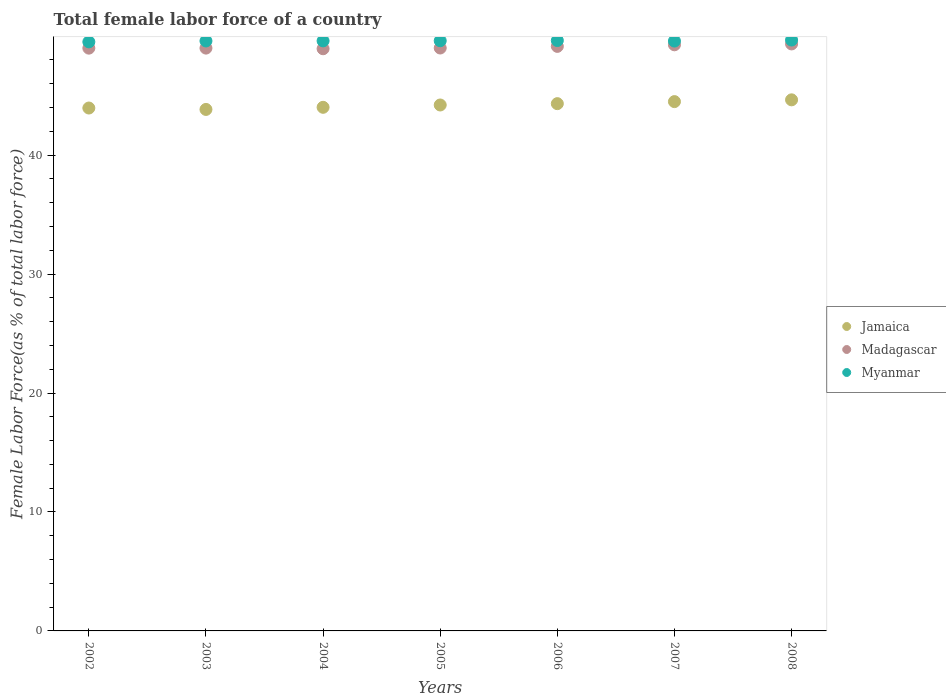How many different coloured dotlines are there?
Provide a succinct answer. 3. What is the percentage of female labor force in Jamaica in 2008?
Provide a short and direct response. 44.65. Across all years, what is the maximum percentage of female labor force in Madagascar?
Make the answer very short. 49.35. Across all years, what is the minimum percentage of female labor force in Jamaica?
Give a very brief answer. 43.84. What is the total percentage of female labor force in Myanmar in the graph?
Ensure brevity in your answer.  347.24. What is the difference between the percentage of female labor force in Jamaica in 2003 and that in 2007?
Ensure brevity in your answer.  -0.66. What is the difference between the percentage of female labor force in Myanmar in 2006 and the percentage of female labor force in Jamaica in 2007?
Provide a succinct answer. 5.13. What is the average percentage of female labor force in Jamaica per year?
Make the answer very short. 44.22. In the year 2002, what is the difference between the percentage of female labor force in Jamaica and percentage of female labor force in Myanmar?
Keep it short and to the point. -5.56. In how many years, is the percentage of female labor force in Madagascar greater than 36 %?
Offer a terse response. 7. What is the ratio of the percentage of female labor force in Myanmar in 2002 to that in 2006?
Ensure brevity in your answer.  1. Is the difference between the percentage of female labor force in Jamaica in 2003 and 2008 greater than the difference between the percentage of female labor force in Myanmar in 2003 and 2008?
Ensure brevity in your answer.  No. What is the difference between the highest and the second highest percentage of female labor force in Jamaica?
Provide a short and direct response. 0.15. What is the difference between the highest and the lowest percentage of female labor force in Myanmar?
Your answer should be very brief. 0.15. Is the sum of the percentage of female labor force in Jamaica in 2004 and 2005 greater than the maximum percentage of female labor force in Madagascar across all years?
Your answer should be very brief. Yes. Does the percentage of female labor force in Madagascar monotonically increase over the years?
Give a very brief answer. No. Is the percentage of female labor force in Jamaica strictly less than the percentage of female labor force in Madagascar over the years?
Your answer should be compact. Yes. How many dotlines are there?
Give a very brief answer. 3. How many years are there in the graph?
Ensure brevity in your answer.  7. Does the graph contain grids?
Your response must be concise. No. Where does the legend appear in the graph?
Your answer should be very brief. Center right. How many legend labels are there?
Your answer should be very brief. 3. How are the legend labels stacked?
Offer a very short reply. Vertical. What is the title of the graph?
Offer a very short reply. Total female labor force of a country. Does "Azerbaijan" appear as one of the legend labels in the graph?
Offer a terse response. No. What is the label or title of the X-axis?
Offer a terse response. Years. What is the label or title of the Y-axis?
Your response must be concise. Female Labor Force(as % of total labor force). What is the Female Labor Force(as % of total labor force) of Jamaica in 2002?
Offer a terse response. 43.96. What is the Female Labor Force(as % of total labor force) in Madagascar in 2002?
Your answer should be compact. 48.99. What is the Female Labor Force(as % of total labor force) of Myanmar in 2002?
Provide a short and direct response. 49.52. What is the Female Labor Force(as % of total labor force) of Jamaica in 2003?
Provide a short and direct response. 43.84. What is the Female Labor Force(as % of total labor force) of Madagascar in 2003?
Give a very brief answer. 49. What is the Female Labor Force(as % of total labor force) of Myanmar in 2003?
Provide a succinct answer. 49.6. What is the Female Labor Force(as % of total labor force) of Jamaica in 2004?
Provide a succinct answer. 44.02. What is the Female Labor Force(as % of total labor force) of Madagascar in 2004?
Make the answer very short. 48.94. What is the Female Labor Force(as % of total labor force) of Myanmar in 2004?
Give a very brief answer. 49.6. What is the Female Labor Force(as % of total labor force) in Jamaica in 2005?
Provide a succinct answer. 44.22. What is the Female Labor Force(as % of total labor force) in Madagascar in 2005?
Provide a succinct answer. 49.01. What is the Female Labor Force(as % of total labor force) of Myanmar in 2005?
Keep it short and to the point. 49.62. What is the Female Labor Force(as % of total labor force) in Jamaica in 2006?
Provide a short and direct response. 44.33. What is the Female Labor Force(as % of total labor force) of Madagascar in 2006?
Keep it short and to the point. 49.14. What is the Female Labor Force(as % of total labor force) in Myanmar in 2006?
Offer a very short reply. 49.63. What is the Female Labor Force(as % of total labor force) of Jamaica in 2007?
Your response must be concise. 44.5. What is the Female Labor Force(as % of total labor force) in Madagascar in 2007?
Keep it short and to the point. 49.28. What is the Female Labor Force(as % of total labor force) in Myanmar in 2007?
Provide a succinct answer. 49.59. What is the Female Labor Force(as % of total labor force) of Jamaica in 2008?
Offer a very short reply. 44.65. What is the Female Labor Force(as % of total labor force) in Madagascar in 2008?
Keep it short and to the point. 49.35. What is the Female Labor Force(as % of total labor force) of Myanmar in 2008?
Keep it short and to the point. 49.68. Across all years, what is the maximum Female Labor Force(as % of total labor force) of Jamaica?
Ensure brevity in your answer.  44.65. Across all years, what is the maximum Female Labor Force(as % of total labor force) in Madagascar?
Provide a succinct answer. 49.35. Across all years, what is the maximum Female Labor Force(as % of total labor force) of Myanmar?
Your answer should be very brief. 49.68. Across all years, what is the minimum Female Labor Force(as % of total labor force) in Jamaica?
Make the answer very short. 43.84. Across all years, what is the minimum Female Labor Force(as % of total labor force) in Madagascar?
Give a very brief answer. 48.94. Across all years, what is the minimum Female Labor Force(as % of total labor force) in Myanmar?
Your answer should be very brief. 49.52. What is the total Female Labor Force(as % of total labor force) of Jamaica in the graph?
Your answer should be very brief. 309.51. What is the total Female Labor Force(as % of total labor force) of Madagascar in the graph?
Ensure brevity in your answer.  343.71. What is the total Female Labor Force(as % of total labor force) in Myanmar in the graph?
Your answer should be compact. 347.24. What is the difference between the Female Labor Force(as % of total labor force) of Jamaica in 2002 and that in 2003?
Your response must be concise. 0.12. What is the difference between the Female Labor Force(as % of total labor force) in Madagascar in 2002 and that in 2003?
Offer a terse response. -0. What is the difference between the Female Labor Force(as % of total labor force) of Myanmar in 2002 and that in 2003?
Keep it short and to the point. -0.08. What is the difference between the Female Labor Force(as % of total labor force) in Jamaica in 2002 and that in 2004?
Make the answer very short. -0.06. What is the difference between the Female Labor Force(as % of total labor force) of Myanmar in 2002 and that in 2004?
Provide a succinct answer. -0.08. What is the difference between the Female Labor Force(as % of total labor force) of Jamaica in 2002 and that in 2005?
Provide a short and direct response. -0.26. What is the difference between the Female Labor Force(as % of total labor force) in Madagascar in 2002 and that in 2005?
Your response must be concise. -0.01. What is the difference between the Female Labor Force(as % of total labor force) of Myanmar in 2002 and that in 2005?
Provide a succinct answer. -0.09. What is the difference between the Female Labor Force(as % of total labor force) in Jamaica in 2002 and that in 2006?
Provide a succinct answer. -0.37. What is the difference between the Female Labor Force(as % of total labor force) of Madagascar in 2002 and that in 2006?
Offer a very short reply. -0.15. What is the difference between the Female Labor Force(as % of total labor force) in Myanmar in 2002 and that in 2006?
Offer a very short reply. -0.11. What is the difference between the Female Labor Force(as % of total labor force) in Jamaica in 2002 and that in 2007?
Your answer should be compact. -0.54. What is the difference between the Female Labor Force(as % of total labor force) in Madagascar in 2002 and that in 2007?
Offer a very short reply. -0.28. What is the difference between the Female Labor Force(as % of total labor force) in Myanmar in 2002 and that in 2007?
Ensure brevity in your answer.  -0.07. What is the difference between the Female Labor Force(as % of total labor force) in Jamaica in 2002 and that in 2008?
Ensure brevity in your answer.  -0.69. What is the difference between the Female Labor Force(as % of total labor force) in Madagascar in 2002 and that in 2008?
Keep it short and to the point. -0.35. What is the difference between the Female Labor Force(as % of total labor force) in Myanmar in 2002 and that in 2008?
Make the answer very short. -0.15. What is the difference between the Female Labor Force(as % of total labor force) of Jamaica in 2003 and that in 2004?
Provide a succinct answer. -0.18. What is the difference between the Female Labor Force(as % of total labor force) of Madagascar in 2003 and that in 2004?
Provide a short and direct response. 0.05. What is the difference between the Female Labor Force(as % of total labor force) in Myanmar in 2003 and that in 2004?
Offer a very short reply. -0.01. What is the difference between the Female Labor Force(as % of total labor force) in Jamaica in 2003 and that in 2005?
Offer a very short reply. -0.37. What is the difference between the Female Labor Force(as % of total labor force) of Madagascar in 2003 and that in 2005?
Give a very brief answer. -0.01. What is the difference between the Female Labor Force(as % of total labor force) of Myanmar in 2003 and that in 2005?
Offer a very short reply. -0.02. What is the difference between the Female Labor Force(as % of total labor force) in Jamaica in 2003 and that in 2006?
Offer a terse response. -0.49. What is the difference between the Female Labor Force(as % of total labor force) in Madagascar in 2003 and that in 2006?
Your answer should be very brief. -0.15. What is the difference between the Female Labor Force(as % of total labor force) of Myanmar in 2003 and that in 2006?
Offer a very short reply. -0.04. What is the difference between the Female Labor Force(as % of total labor force) in Jamaica in 2003 and that in 2007?
Your response must be concise. -0.66. What is the difference between the Female Labor Force(as % of total labor force) in Madagascar in 2003 and that in 2007?
Your response must be concise. -0.28. What is the difference between the Female Labor Force(as % of total labor force) in Myanmar in 2003 and that in 2007?
Make the answer very short. 0.01. What is the difference between the Female Labor Force(as % of total labor force) of Jamaica in 2003 and that in 2008?
Offer a terse response. -0.81. What is the difference between the Female Labor Force(as % of total labor force) in Madagascar in 2003 and that in 2008?
Make the answer very short. -0.35. What is the difference between the Female Labor Force(as % of total labor force) in Myanmar in 2003 and that in 2008?
Ensure brevity in your answer.  -0.08. What is the difference between the Female Labor Force(as % of total labor force) in Jamaica in 2004 and that in 2005?
Your answer should be very brief. -0.2. What is the difference between the Female Labor Force(as % of total labor force) of Madagascar in 2004 and that in 2005?
Offer a terse response. -0.06. What is the difference between the Female Labor Force(as % of total labor force) in Myanmar in 2004 and that in 2005?
Provide a short and direct response. -0.01. What is the difference between the Female Labor Force(as % of total labor force) of Jamaica in 2004 and that in 2006?
Make the answer very short. -0.31. What is the difference between the Female Labor Force(as % of total labor force) of Madagascar in 2004 and that in 2006?
Your answer should be compact. -0.2. What is the difference between the Female Labor Force(as % of total labor force) in Myanmar in 2004 and that in 2006?
Keep it short and to the point. -0.03. What is the difference between the Female Labor Force(as % of total labor force) in Jamaica in 2004 and that in 2007?
Keep it short and to the point. -0.48. What is the difference between the Female Labor Force(as % of total labor force) in Madagascar in 2004 and that in 2007?
Provide a short and direct response. -0.33. What is the difference between the Female Labor Force(as % of total labor force) in Myanmar in 2004 and that in 2007?
Offer a very short reply. 0.02. What is the difference between the Female Labor Force(as % of total labor force) in Jamaica in 2004 and that in 2008?
Ensure brevity in your answer.  -0.63. What is the difference between the Female Labor Force(as % of total labor force) of Madagascar in 2004 and that in 2008?
Your answer should be compact. -0.41. What is the difference between the Female Labor Force(as % of total labor force) in Myanmar in 2004 and that in 2008?
Your answer should be compact. -0.07. What is the difference between the Female Labor Force(as % of total labor force) in Jamaica in 2005 and that in 2006?
Ensure brevity in your answer.  -0.11. What is the difference between the Female Labor Force(as % of total labor force) in Madagascar in 2005 and that in 2006?
Keep it short and to the point. -0.14. What is the difference between the Female Labor Force(as % of total labor force) in Myanmar in 2005 and that in 2006?
Make the answer very short. -0.02. What is the difference between the Female Labor Force(as % of total labor force) in Jamaica in 2005 and that in 2007?
Your answer should be very brief. -0.28. What is the difference between the Female Labor Force(as % of total labor force) of Madagascar in 2005 and that in 2007?
Keep it short and to the point. -0.27. What is the difference between the Female Labor Force(as % of total labor force) in Myanmar in 2005 and that in 2007?
Keep it short and to the point. 0.03. What is the difference between the Female Labor Force(as % of total labor force) in Jamaica in 2005 and that in 2008?
Provide a short and direct response. -0.43. What is the difference between the Female Labor Force(as % of total labor force) in Madagascar in 2005 and that in 2008?
Give a very brief answer. -0.34. What is the difference between the Female Labor Force(as % of total labor force) of Myanmar in 2005 and that in 2008?
Your answer should be compact. -0.06. What is the difference between the Female Labor Force(as % of total labor force) in Jamaica in 2006 and that in 2007?
Provide a short and direct response. -0.17. What is the difference between the Female Labor Force(as % of total labor force) of Madagascar in 2006 and that in 2007?
Give a very brief answer. -0.13. What is the difference between the Female Labor Force(as % of total labor force) in Myanmar in 2006 and that in 2007?
Your answer should be compact. 0.04. What is the difference between the Female Labor Force(as % of total labor force) in Jamaica in 2006 and that in 2008?
Offer a terse response. -0.32. What is the difference between the Female Labor Force(as % of total labor force) of Madagascar in 2006 and that in 2008?
Your answer should be very brief. -0.21. What is the difference between the Female Labor Force(as % of total labor force) of Myanmar in 2006 and that in 2008?
Provide a short and direct response. -0.04. What is the difference between the Female Labor Force(as % of total labor force) of Jamaica in 2007 and that in 2008?
Give a very brief answer. -0.15. What is the difference between the Female Labor Force(as % of total labor force) of Madagascar in 2007 and that in 2008?
Provide a short and direct response. -0.07. What is the difference between the Female Labor Force(as % of total labor force) in Myanmar in 2007 and that in 2008?
Give a very brief answer. -0.09. What is the difference between the Female Labor Force(as % of total labor force) of Jamaica in 2002 and the Female Labor Force(as % of total labor force) of Madagascar in 2003?
Ensure brevity in your answer.  -5.04. What is the difference between the Female Labor Force(as % of total labor force) in Jamaica in 2002 and the Female Labor Force(as % of total labor force) in Myanmar in 2003?
Make the answer very short. -5.64. What is the difference between the Female Labor Force(as % of total labor force) in Madagascar in 2002 and the Female Labor Force(as % of total labor force) in Myanmar in 2003?
Keep it short and to the point. -0.6. What is the difference between the Female Labor Force(as % of total labor force) in Jamaica in 2002 and the Female Labor Force(as % of total labor force) in Madagascar in 2004?
Keep it short and to the point. -4.98. What is the difference between the Female Labor Force(as % of total labor force) in Jamaica in 2002 and the Female Labor Force(as % of total labor force) in Myanmar in 2004?
Keep it short and to the point. -5.65. What is the difference between the Female Labor Force(as % of total labor force) in Madagascar in 2002 and the Female Labor Force(as % of total labor force) in Myanmar in 2004?
Ensure brevity in your answer.  -0.61. What is the difference between the Female Labor Force(as % of total labor force) of Jamaica in 2002 and the Female Labor Force(as % of total labor force) of Madagascar in 2005?
Offer a very short reply. -5.05. What is the difference between the Female Labor Force(as % of total labor force) of Jamaica in 2002 and the Female Labor Force(as % of total labor force) of Myanmar in 2005?
Provide a short and direct response. -5.66. What is the difference between the Female Labor Force(as % of total labor force) in Madagascar in 2002 and the Female Labor Force(as % of total labor force) in Myanmar in 2005?
Offer a very short reply. -0.62. What is the difference between the Female Labor Force(as % of total labor force) in Jamaica in 2002 and the Female Labor Force(as % of total labor force) in Madagascar in 2006?
Provide a short and direct response. -5.18. What is the difference between the Female Labor Force(as % of total labor force) of Jamaica in 2002 and the Female Labor Force(as % of total labor force) of Myanmar in 2006?
Provide a succinct answer. -5.67. What is the difference between the Female Labor Force(as % of total labor force) of Madagascar in 2002 and the Female Labor Force(as % of total labor force) of Myanmar in 2006?
Offer a very short reply. -0.64. What is the difference between the Female Labor Force(as % of total labor force) of Jamaica in 2002 and the Female Labor Force(as % of total labor force) of Madagascar in 2007?
Make the answer very short. -5.32. What is the difference between the Female Labor Force(as % of total labor force) in Jamaica in 2002 and the Female Labor Force(as % of total labor force) in Myanmar in 2007?
Your answer should be very brief. -5.63. What is the difference between the Female Labor Force(as % of total labor force) of Madagascar in 2002 and the Female Labor Force(as % of total labor force) of Myanmar in 2007?
Ensure brevity in your answer.  -0.6. What is the difference between the Female Labor Force(as % of total labor force) of Jamaica in 2002 and the Female Labor Force(as % of total labor force) of Madagascar in 2008?
Give a very brief answer. -5.39. What is the difference between the Female Labor Force(as % of total labor force) of Jamaica in 2002 and the Female Labor Force(as % of total labor force) of Myanmar in 2008?
Offer a terse response. -5.72. What is the difference between the Female Labor Force(as % of total labor force) of Madagascar in 2002 and the Female Labor Force(as % of total labor force) of Myanmar in 2008?
Your answer should be compact. -0.68. What is the difference between the Female Labor Force(as % of total labor force) in Jamaica in 2003 and the Female Labor Force(as % of total labor force) in Madagascar in 2004?
Your answer should be compact. -5.1. What is the difference between the Female Labor Force(as % of total labor force) of Jamaica in 2003 and the Female Labor Force(as % of total labor force) of Myanmar in 2004?
Make the answer very short. -5.76. What is the difference between the Female Labor Force(as % of total labor force) in Madagascar in 2003 and the Female Labor Force(as % of total labor force) in Myanmar in 2004?
Ensure brevity in your answer.  -0.61. What is the difference between the Female Labor Force(as % of total labor force) in Jamaica in 2003 and the Female Labor Force(as % of total labor force) in Madagascar in 2005?
Keep it short and to the point. -5.16. What is the difference between the Female Labor Force(as % of total labor force) of Jamaica in 2003 and the Female Labor Force(as % of total labor force) of Myanmar in 2005?
Your answer should be compact. -5.77. What is the difference between the Female Labor Force(as % of total labor force) in Madagascar in 2003 and the Female Labor Force(as % of total labor force) in Myanmar in 2005?
Give a very brief answer. -0.62. What is the difference between the Female Labor Force(as % of total labor force) in Jamaica in 2003 and the Female Labor Force(as % of total labor force) in Madagascar in 2006?
Make the answer very short. -5.3. What is the difference between the Female Labor Force(as % of total labor force) of Jamaica in 2003 and the Female Labor Force(as % of total labor force) of Myanmar in 2006?
Make the answer very short. -5.79. What is the difference between the Female Labor Force(as % of total labor force) in Madagascar in 2003 and the Female Labor Force(as % of total labor force) in Myanmar in 2006?
Keep it short and to the point. -0.64. What is the difference between the Female Labor Force(as % of total labor force) of Jamaica in 2003 and the Female Labor Force(as % of total labor force) of Madagascar in 2007?
Provide a succinct answer. -5.43. What is the difference between the Female Labor Force(as % of total labor force) of Jamaica in 2003 and the Female Labor Force(as % of total labor force) of Myanmar in 2007?
Your response must be concise. -5.75. What is the difference between the Female Labor Force(as % of total labor force) in Madagascar in 2003 and the Female Labor Force(as % of total labor force) in Myanmar in 2007?
Ensure brevity in your answer.  -0.59. What is the difference between the Female Labor Force(as % of total labor force) of Jamaica in 2003 and the Female Labor Force(as % of total labor force) of Madagascar in 2008?
Your answer should be very brief. -5.51. What is the difference between the Female Labor Force(as % of total labor force) in Jamaica in 2003 and the Female Labor Force(as % of total labor force) in Myanmar in 2008?
Provide a succinct answer. -5.83. What is the difference between the Female Labor Force(as % of total labor force) of Madagascar in 2003 and the Female Labor Force(as % of total labor force) of Myanmar in 2008?
Make the answer very short. -0.68. What is the difference between the Female Labor Force(as % of total labor force) of Jamaica in 2004 and the Female Labor Force(as % of total labor force) of Madagascar in 2005?
Offer a very short reply. -4.99. What is the difference between the Female Labor Force(as % of total labor force) of Jamaica in 2004 and the Female Labor Force(as % of total labor force) of Myanmar in 2005?
Ensure brevity in your answer.  -5.6. What is the difference between the Female Labor Force(as % of total labor force) of Madagascar in 2004 and the Female Labor Force(as % of total labor force) of Myanmar in 2005?
Provide a succinct answer. -0.67. What is the difference between the Female Labor Force(as % of total labor force) in Jamaica in 2004 and the Female Labor Force(as % of total labor force) in Madagascar in 2006?
Your response must be concise. -5.12. What is the difference between the Female Labor Force(as % of total labor force) in Jamaica in 2004 and the Female Labor Force(as % of total labor force) in Myanmar in 2006?
Keep it short and to the point. -5.61. What is the difference between the Female Labor Force(as % of total labor force) of Madagascar in 2004 and the Female Labor Force(as % of total labor force) of Myanmar in 2006?
Provide a succinct answer. -0.69. What is the difference between the Female Labor Force(as % of total labor force) of Jamaica in 2004 and the Female Labor Force(as % of total labor force) of Madagascar in 2007?
Offer a very short reply. -5.26. What is the difference between the Female Labor Force(as % of total labor force) in Jamaica in 2004 and the Female Labor Force(as % of total labor force) in Myanmar in 2007?
Your answer should be very brief. -5.57. What is the difference between the Female Labor Force(as % of total labor force) in Madagascar in 2004 and the Female Labor Force(as % of total labor force) in Myanmar in 2007?
Provide a short and direct response. -0.65. What is the difference between the Female Labor Force(as % of total labor force) of Jamaica in 2004 and the Female Labor Force(as % of total labor force) of Madagascar in 2008?
Give a very brief answer. -5.33. What is the difference between the Female Labor Force(as % of total labor force) in Jamaica in 2004 and the Female Labor Force(as % of total labor force) in Myanmar in 2008?
Give a very brief answer. -5.66. What is the difference between the Female Labor Force(as % of total labor force) of Madagascar in 2004 and the Female Labor Force(as % of total labor force) of Myanmar in 2008?
Keep it short and to the point. -0.73. What is the difference between the Female Labor Force(as % of total labor force) of Jamaica in 2005 and the Female Labor Force(as % of total labor force) of Madagascar in 2006?
Provide a succinct answer. -4.93. What is the difference between the Female Labor Force(as % of total labor force) in Jamaica in 2005 and the Female Labor Force(as % of total labor force) in Myanmar in 2006?
Your answer should be compact. -5.42. What is the difference between the Female Labor Force(as % of total labor force) of Madagascar in 2005 and the Female Labor Force(as % of total labor force) of Myanmar in 2006?
Offer a very short reply. -0.63. What is the difference between the Female Labor Force(as % of total labor force) in Jamaica in 2005 and the Female Labor Force(as % of total labor force) in Madagascar in 2007?
Your response must be concise. -5.06. What is the difference between the Female Labor Force(as % of total labor force) in Jamaica in 2005 and the Female Labor Force(as % of total labor force) in Myanmar in 2007?
Give a very brief answer. -5.37. What is the difference between the Female Labor Force(as % of total labor force) in Madagascar in 2005 and the Female Labor Force(as % of total labor force) in Myanmar in 2007?
Provide a succinct answer. -0.58. What is the difference between the Female Labor Force(as % of total labor force) of Jamaica in 2005 and the Female Labor Force(as % of total labor force) of Madagascar in 2008?
Offer a terse response. -5.13. What is the difference between the Female Labor Force(as % of total labor force) of Jamaica in 2005 and the Female Labor Force(as % of total labor force) of Myanmar in 2008?
Provide a succinct answer. -5.46. What is the difference between the Female Labor Force(as % of total labor force) in Madagascar in 2005 and the Female Labor Force(as % of total labor force) in Myanmar in 2008?
Ensure brevity in your answer.  -0.67. What is the difference between the Female Labor Force(as % of total labor force) in Jamaica in 2006 and the Female Labor Force(as % of total labor force) in Madagascar in 2007?
Make the answer very short. -4.95. What is the difference between the Female Labor Force(as % of total labor force) of Jamaica in 2006 and the Female Labor Force(as % of total labor force) of Myanmar in 2007?
Ensure brevity in your answer.  -5.26. What is the difference between the Female Labor Force(as % of total labor force) in Madagascar in 2006 and the Female Labor Force(as % of total labor force) in Myanmar in 2007?
Your response must be concise. -0.45. What is the difference between the Female Labor Force(as % of total labor force) of Jamaica in 2006 and the Female Labor Force(as % of total labor force) of Madagascar in 2008?
Your answer should be compact. -5.02. What is the difference between the Female Labor Force(as % of total labor force) of Jamaica in 2006 and the Female Labor Force(as % of total labor force) of Myanmar in 2008?
Ensure brevity in your answer.  -5.35. What is the difference between the Female Labor Force(as % of total labor force) of Madagascar in 2006 and the Female Labor Force(as % of total labor force) of Myanmar in 2008?
Ensure brevity in your answer.  -0.53. What is the difference between the Female Labor Force(as % of total labor force) of Jamaica in 2007 and the Female Labor Force(as % of total labor force) of Madagascar in 2008?
Your answer should be very brief. -4.85. What is the difference between the Female Labor Force(as % of total labor force) in Jamaica in 2007 and the Female Labor Force(as % of total labor force) in Myanmar in 2008?
Your answer should be very brief. -5.18. What is the difference between the Female Labor Force(as % of total labor force) in Madagascar in 2007 and the Female Labor Force(as % of total labor force) in Myanmar in 2008?
Offer a very short reply. -0.4. What is the average Female Labor Force(as % of total labor force) of Jamaica per year?
Provide a short and direct response. 44.22. What is the average Female Labor Force(as % of total labor force) in Madagascar per year?
Your response must be concise. 49.1. What is the average Female Labor Force(as % of total labor force) in Myanmar per year?
Give a very brief answer. 49.61. In the year 2002, what is the difference between the Female Labor Force(as % of total labor force) in Jamaica and Female Labor Force(as % of total labor force) in Madagascar?
Make the answer very short. -5.03. In the year 2002, what is the difference between the Female Labor Force(as % of total labor force) of Jamaica and Female Labor Force(as % of total labor force) of Myanmar?
Offer a terse response. -5.56. In the year 2002, what is the difference between the Female Labor Force(as % of total labor force) of Madagascar and Female Labor Force(as % of total labor force) of Myanmar?
Provide a short and direct response. -0.53. In the year 2003, what is the difference between the Female Labor Force(as % of total labor force) in Jamaica and Female Labor Force(as % of total labor force) in Madagascar?
Your response must be concise. -5.16. In the year 2003, what is the difference between the Female Labor Force(as % of total labor force) in Jamaica and Female Labor Force(as % of total labor force) in Myanmar?
Your answer should be compact. -5.76. In the year 2003, what is the difference between the Female Labor Force(as % of total labor force) of Madagascar and Female Labor Force(as % of total labor force) of Myanmar?
Give a very brief answer. -0.6. In the year 2004, what is the difference between the Female Labor Force(as % of total labor force) of Jamaica and Female Labor Force(as % of total labor force) of Madagascar?
Keep it short and to the point. -4.92. In the year 2004, what is the difference between the Female Labor Force(as % of total labor force) of Jamaica and Female Labor Force(as % of total labor force) of Myanmar?
Give a very brief answer. -5.58. In the year 2004, what is the difference between the Female Labor Force(as % of total labor force) of Madagascar and Female Labor Force(as % of total labor force) of Myanmar?
Provide a short and direct response. -0.66. In the year 2005, what is the difference between the Female Labor Force(as % of total labor force) of Jamaica and Female Labor Force(as % of total labor force) of Madagascar?
Your answer should be compact. -4.79. In the year 2005, what is the difference between the Female Labor Force(as % of total labor force) of Jamaica and Female Labor Force(as % of total labor force) of Myanmar?
Your answer should be compact. -5.4. In the year 2005, what is the difference between the Female Labor Force(as % of total labor force) of Madagascar and Female Labor Force(as % of total labor force) of Myanmar?
Keep it short and to the point. -0.61. In the year 2006, what is the difference between the Female Labor Force(as % of total labor force) in Jamaica and Female Labor Force(as % of total labor force) in Madagascar?
Offer a terse response. -4.82. In the year 2006, what is the difference between the Female Labor Force(as % of total labor force) of Jamaica and Female Labor Force(as % of total labor force) of Myanmar?
Your response must be concise. -5.31. In the year 2006, what is the difference between the Female Labor Force(as % of total labor force) of Madagascar and Female Labor Force(as % of total labor force) of Myanmar?
Your response must be concise. -0.49. In the year 2007, what is the difference between the Female Labor Force(as % of total labor force) of Jamaica and Female Labor Force(as % of total labor force) of Madagascar?
Your response must be concise. -4.78. In the year 2007, what is the difference between the Female Labor Force(as % of total labor force) of Jamaica and Female Labor Force(as % of total labor force) of Myanmar?
Provide a short and direct response. -5.09. In the year 2007, what is the difference between the Female Labor Force(as % of total labor force) in Madagascar and Female Labor Force(as % of total labor force) in Myanmar?
Keep it short and to the point. -0.31. In the year 2008, what is the difference between the Female Labor Force(as % of total labor force) in Jamaica and Female Labor Force(as % of total labor force) in Madagascar?
Provide a short and direct response. -4.7. In the year 2008, what is the difference between the Female Labor Force(as % of total labor force) in Jamaica and Female Labor Force(as % of total labor force) in Myanmar?
Your response must be concise. -5.03. In the year 2008, what is the difference between the Female Labor Force(as % of total labor force) of Madagascar and Female Labor Force(as % of total labor force) of Myanmar?
Your answer should be very brief. -0.33. What is the ratio of the Female Labor Force(as % of total labor force) in Jamaica in 2002 to that in 2003?
Ensure brevity in your answer.  1. What is the ratio of the Female Labor Force(as % of total labor force) in Myanmar in 2002 to that in 2003?
Provide a succinct answer. 1. What is the ratio of the Female Labor Force(as % of total labor force) of Jamaica in 2002 to that in 2005?
Make the answer very short. 0.99. What is the ratio of the Female Labor Force(as % of total labor force) in Myanmar in 2002 to that in 2005?
Offer a very short reply. 1. What is the ratio of the Female Labor Force(as % of total labor force) of Madagascar in 2002 to that in 2006?
Ensure brevity in your answer.  1. What is the ratio of the Female Labor Force(as % of total labor force) of Myanmar in 2002 to that in 2006?
Give a very brief answer. 1. What is the ratio of the Female Labor Force(as % of total labor force) of Jamaica in 2002 to that in 2007?
Your response must be concise. 0.99. What is the ratio of the Female Labor Force(as % of total labor force) in Madagascar in 2002 to that in 2007?
Give a very brief answer. 0.99. What is the ratio of the Female Labor Force(as % of total labor force) of Jamaica in 2002 to that in 2008?
Your answer should be compact. 0.98. What is the ratio of the Female Labor Force(as % of total labor force) in Myanmar in 2003 to that in 2004?
Make the answer very short. 1. What is the ratio of the Female Labor Force(as % of total labor force) of Jamaica in 2003 to that in 2005?
Keep it short and to the point. 0.99. What is the ratio of the Female Labor Force(as % of total labor force) of Myanmar in 2003 to that in 2005?
Ensure brevity in your answer.  1. What is the ratio of the Female Labor Force(as % of total labor force) of Jamaica in 2003 to that in 2006?
Your answer should be compact. 0.99. What is the ratio of the Female Labor Force(as % of total labor force) of Madagascar in 2003 to that in 2006?
Give a very brief answer. 1. What is the ratio of the Female Labor Force(as % of total labor force) of Myanmar in 2003 to that in 2006?
Your answer should be very brief. 1. What is the ratio of the Female Labor Force(as % of total labor force) in Jamaica in 2003 to that in 2007?
Make the answer very short. 0.99. What is the ratio of the Female Labor Force(as % of total labor force) of Madagascar in 2003 to that in 2007?
Give a very brief answer. 0.99. What is the ratio of the Female Labor Force(as % of total labor force) of Myanmar in 2003 to that in 2007?
Your answer should be very brief. 1. What is the ratio of the Female Labor Force(as % of total labor force) of Jamaica in 2003 to that in 2008?
Your answer should be compact. 0.98. What is the ratio of the Female Labor Force(as % of total labor force) in Myanmar in 2003 to that in 2008?
Your answer should be very brief. 1. What is the ratio of the Female Labor Force(as % of total labor force) of Madagascar in 2004 to that in 2005?
Provide a succinct answer. 1. What is the ratio of the Female Labor Force(as % of total labor force) of Myanmar in 2004 to that in 2005?
Give a very brief answer. 1. What is the ratio of the Female Labor Force(as % of total labor force) of Madagascar in 2004 to that in 2006?
Make the answer very short. 1. What is the ratio of the Female Labor Force(as % of total labor force) in Jamaica in 2004 to that in 2007?
Keep it short and to the point. 0.99. What is the ratio of the Female Labor Force(as % of total labor force) in Madagascar in 2004 to that in 2007?
Ensure brevity in your answer.  0.99. What is the ratio of the Female Labor Force(as % of total labor force) of Jamaica in 2004 to that in 2008?
Offer a very short reply. 0.99. What is the ratio of the Female Labor Force(as % of total labor force) of Jamaica in 2005 to that in 2006?
Offer a terse response. 1. What is the ratio of the Female Labor Force(as % of total labor force) in Madagascar in 2005 to that in 2006?
Your response must be concise. 1. What is the ratio of the Female Labor Force(as % of total labor force) in Myanmar in 2005 to that in 2006?
Make the answer very short. 1. What is the ratio of the Female Labor Force(as % of total labor force) in Jamaica in 2005 to that in 2007?
Offer a terse response. 0.99. What is the ratio of the Female Labor Force(as % of total labor force) of Myanmar in 2005 to that in 2007?
Keep it short and to the point. 1. What is the ratio of the Female Labor Force(as % of total labor force) of Jamaica in 2005 to that in 2008?
Your answer should be compact. 0.99. What is the ratio of the Female Labor Force(as % of total labor force) of Madagascar in 2005 to that in 2008?
Your answer should be compact. 0.99. What is the ratio of the Female Labor Force(as % of total labor force) of Madagascar in 2006 to that in 2007?
Give a very brief answer. 1. What is the ratio of the Female Labor Force(as % of total labor force) of Myanmar in 2006 to that in 2007?
Ensure brevity in your answer.  1. What is the ratio of the Female Labor Force(as % of total labor force) in Jamaica in 2006 to that in 2008?
Your response must be concise. 0.99. What is the difference between the highest and the second highest Female Labor Force(as % of total labor force) in Jamaica?
Offer a very short reply. 0.15. What is the difference between the highest and the second highest Female Labor Force(as % of total labor force) of Madagascar?
Your answer should be very brief. 0.07. What is the difference between the highest and the second highest Female Labor Force(as % of total labor force) of Myanmar?
Your response must be concise. 0.04. What is the difference between the highest and the lowest Female Labor Force(as % of total labor force) of Jamaica?
Ensure brevity in your answer.  0.81. What is the difference between the highest and the lowest Female Labor Force(as % of total labor force) of Madagascar?
Provide a succinct answer. 0.41. What is the difference between the highest and the lowest Female Labor Force(as % of total labor force) of Myanmar?
Make the answer very short. 0.15. 